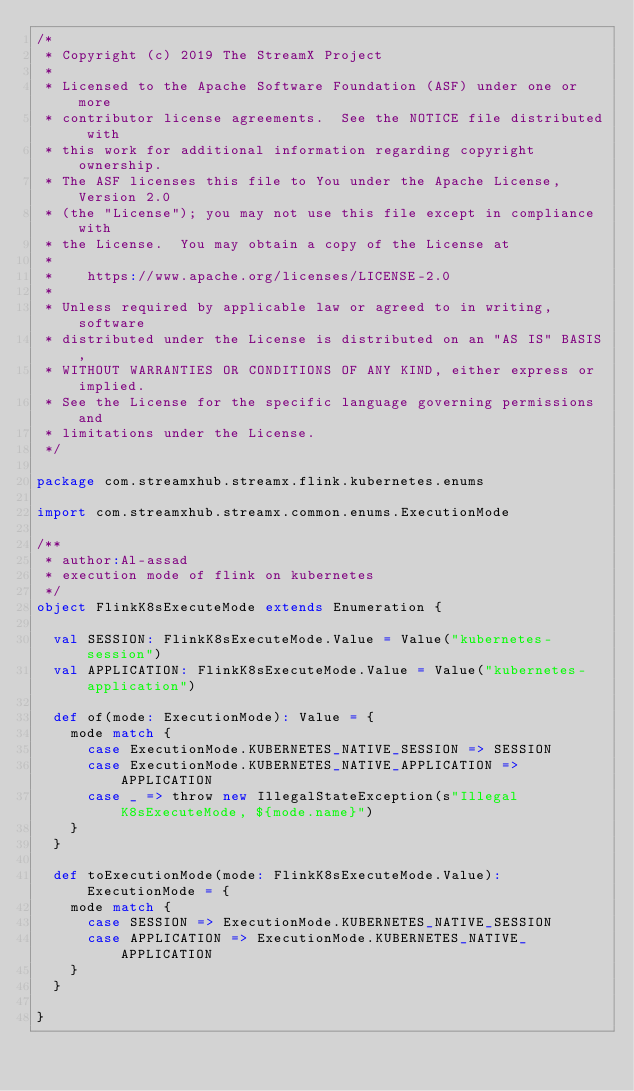Convert code to text. <code><loc_0><loc_0><loc_500><loc_500><_Scala_>/*
 * Copyright (c) 2019 The StreamX Project
 *
 * Licensed to the Apache Software Foundation (ASF) under one or more
 * contributor license agreements.  See the NOTICE file distributed with
 * this work for additional information regarding copyright ownership.
 * The ASF licenses this file to You under the Apache License, Version 2.0
 * (the "License"); you may not use this file except in compliance with
 * the License.  You may obtain a copy of the License at
 *
 *    https://www.apache.org/licenses/LICENSE-2.0
 *
 * Unless required by applicable law or agreed to in writing, software
 * distributed under the License is distributed on an "AS IS" BASIS,
 * WITHOUT WARRANTIES OR CONDITIONS OF ANY KIND, either express or implied.
 * See the License for the specific language governing permissions and
 * limitations under the License.
 */

package com.streamxhub.streamx.flink.kubernetes.enums

import com.streamxhub.streamx.common.enums.ExecutionMode

/**
 * author:Al-assad
 * execution mode of flink on kubernetes
 */
object FlinkK8sExecuteMode extends Enumeration {

  val SESSION: FlinkK8sExecuteMode.Value = Value("kubernetes-session")
  val APPLICATION: FlinkK8sExecuteMode.Value = Value("kubernetes-application")

  def of(mode: ExecutionMode): Value = {
    mode match {
      case ExecutionMode.KUBERNETES_NATIVE_SESSION => SESSION
      case ExecutionMode.KUBERNETES_NATIVE_APPLICATION => APPLICATION
      case _ => throw new IllegalStateException(s"Illegal K8sExecuteMode, ${mode.name}")
    }
  }

  def toExecutionMode(mode: FlinkK8sExecuteMode.Value): ExecutionMode = {
    mode match {
      case SESSION => ExecutionMode.KUBERNETES_NATIVE_SESSION
      case APPLICATION => ExecutionMode.KUBERNETES_NATIVE_APPLICATION
    }
  }

}
</code> 